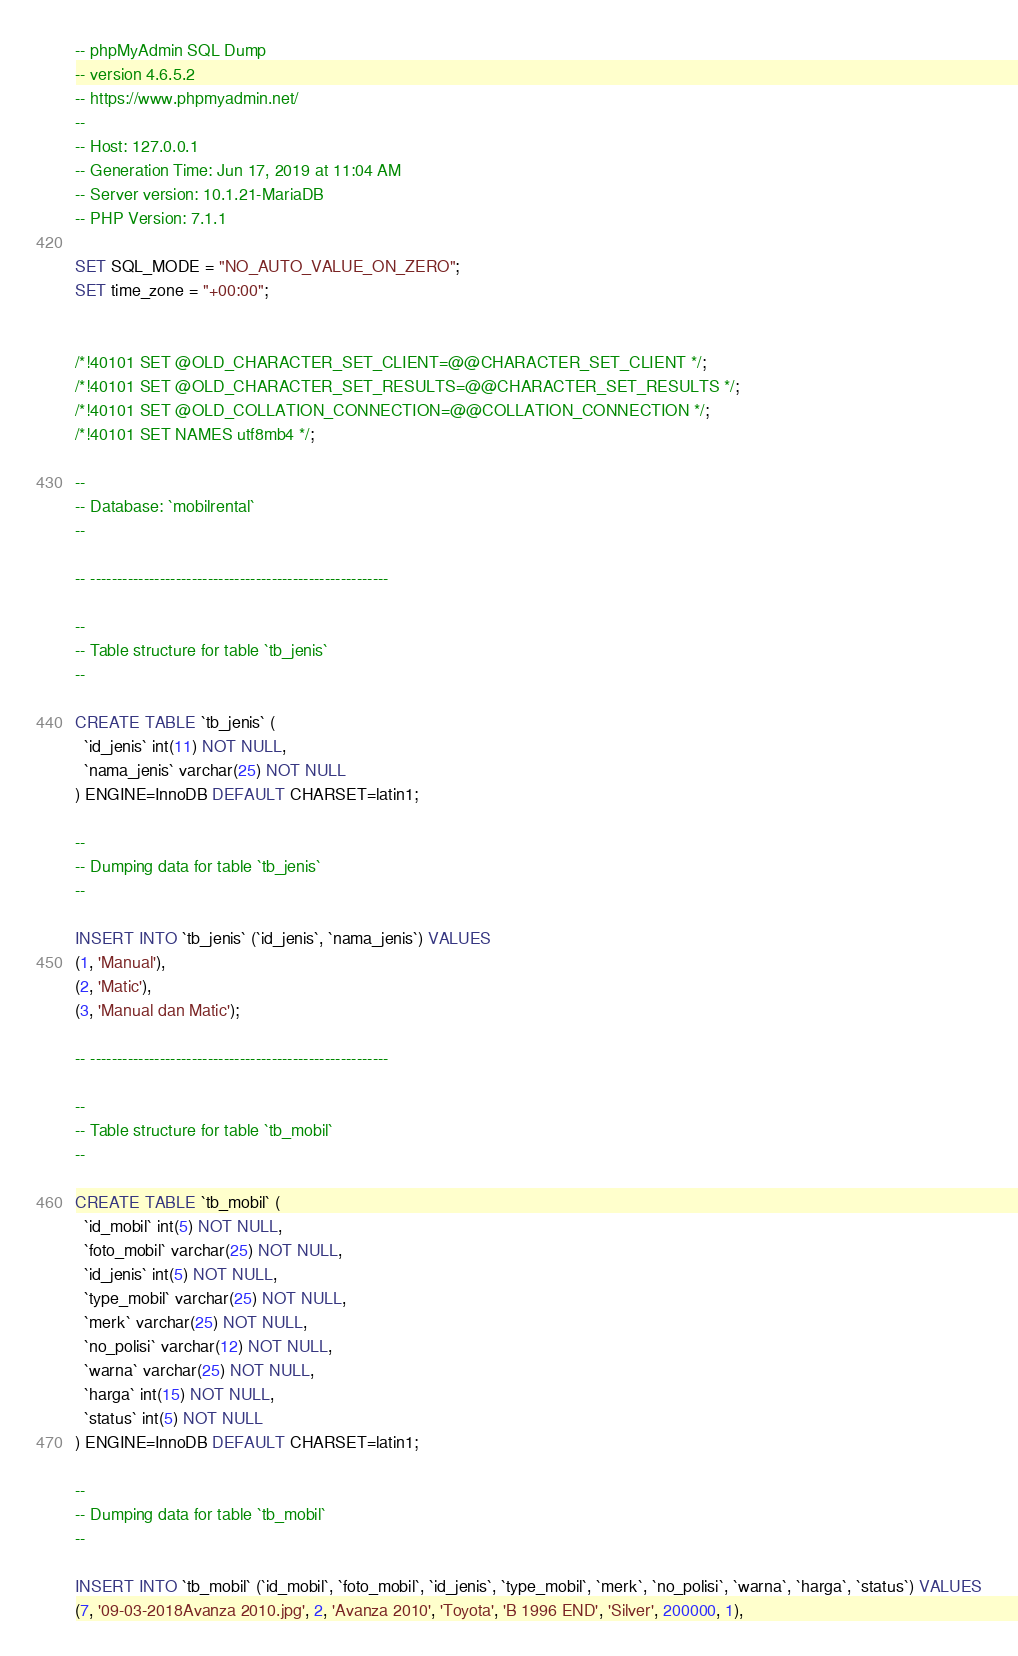<code> <loc_0><loc_0><loc_500><loc_500><_SQL_>-- phpMyAdmin SQL Dump
-- version 4.6.5.2
-- https://www.phpmyadmin.net/
--
-- Host: 127.0.0.1
-- Generation Time: Jun 17, 2019 at 11:04 AM
-- Server version: 10.1.21-MariaDB
-- PHP Version: 7.1.1

SET SQL_MODE = "NO_AUTO_VALUE_ON_ZERO";
SET time_zone = "+00:00";


/*!40101 SET @OLD_CHARACTER_SET_CLIENT=@@CHARACTER_SET_CLIENT */;
/*!40101 SET @OLD_CHARACTER_SET_RESULTS=@@CHARACTER_SET_RESULTS */;
/*!40101 SET @OLD_COLLATION_CONNECTION=@@COLLATION_CONNECTION */;
/*!40101 SET NAMES utf8mb4 */;

--
-- Database: `mobilrental`
--

-- --------------------------------------------------------

--
-- Table structure for table `tb_jenis`
--

CREATE TABLE `tb_jenis` (
  `id_jenis` int(11) NOT NULL,
  `nama_jenis` varchar(25) NOT NULL
) ENGINE=InnoDB DEFAULT CHARSET=latin1;

--
-- Dumping data for table `tb_jenis`
--

INSERT INTO `tb_jenis` (`id_jenis`, `nama_jenis`) VALUES
(1, 'Manual'),
(2, 'Matic'),
(3, 'Manual dan Matic');

-- --------------------------------------------------------

--
-- Table structure for table `tb_mobil`
--

CREATE TABLE `tb_mobil` (
  `id_mobil` int(5) NOT NULL,
  `foto_mobil` varchar(25) NOT NULL,
  `id_jenis` int(5) NOT NULL,
  `type_mobil` varchar(25) NOT NULL,
  `merk` varchar(25) NOT NULL,
  `no_polisi` varchar(12) NOT NULL,
  `warna` varchar(25) NOT NULL,
  `harga` int(15) NOT NULL,
  `status` int(5) NOT NULL
) ENGINE=InnoDB DEFAULT CHARSET=latin1;

--
-- Dumping data for table `tb_mobil`
--

INSERT INTO `tb_mobil` (`id_mobil`, `foto_mobil`, `id_jenis`, `type_mobil`, `merk`, `no_polisi`, `warna`, `harga`, `status`) VALUES
(7, '09-03-2018Avanza 2010.jpg', 2, 'Avanza 2010', 'Toyota', 'B 1996 END', 'Silver', 200000, 1),</code> 